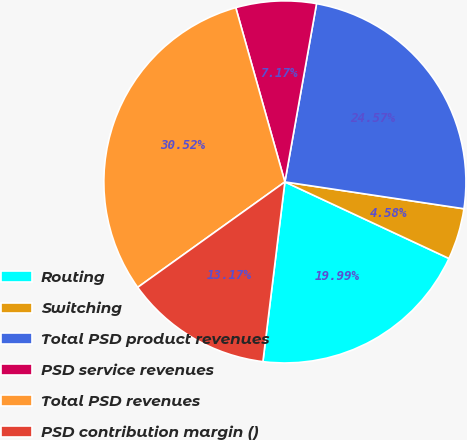Convert chart. <chart><loc_0><loc_0><loc_500><loc_500><pie_chart><fcel>Routing<fcel>Switching<fcel>Total PSD product revenues<fcel>PSD service revenues<fcel>Total PSD revenues<fcel>PSD contribution margin ()<nl><fcel>19.99%<fcel>4.58%<fcel>24.57%<fcel>7.17%<fcel>30.52%<fcel>13.17%<nl></chart> 